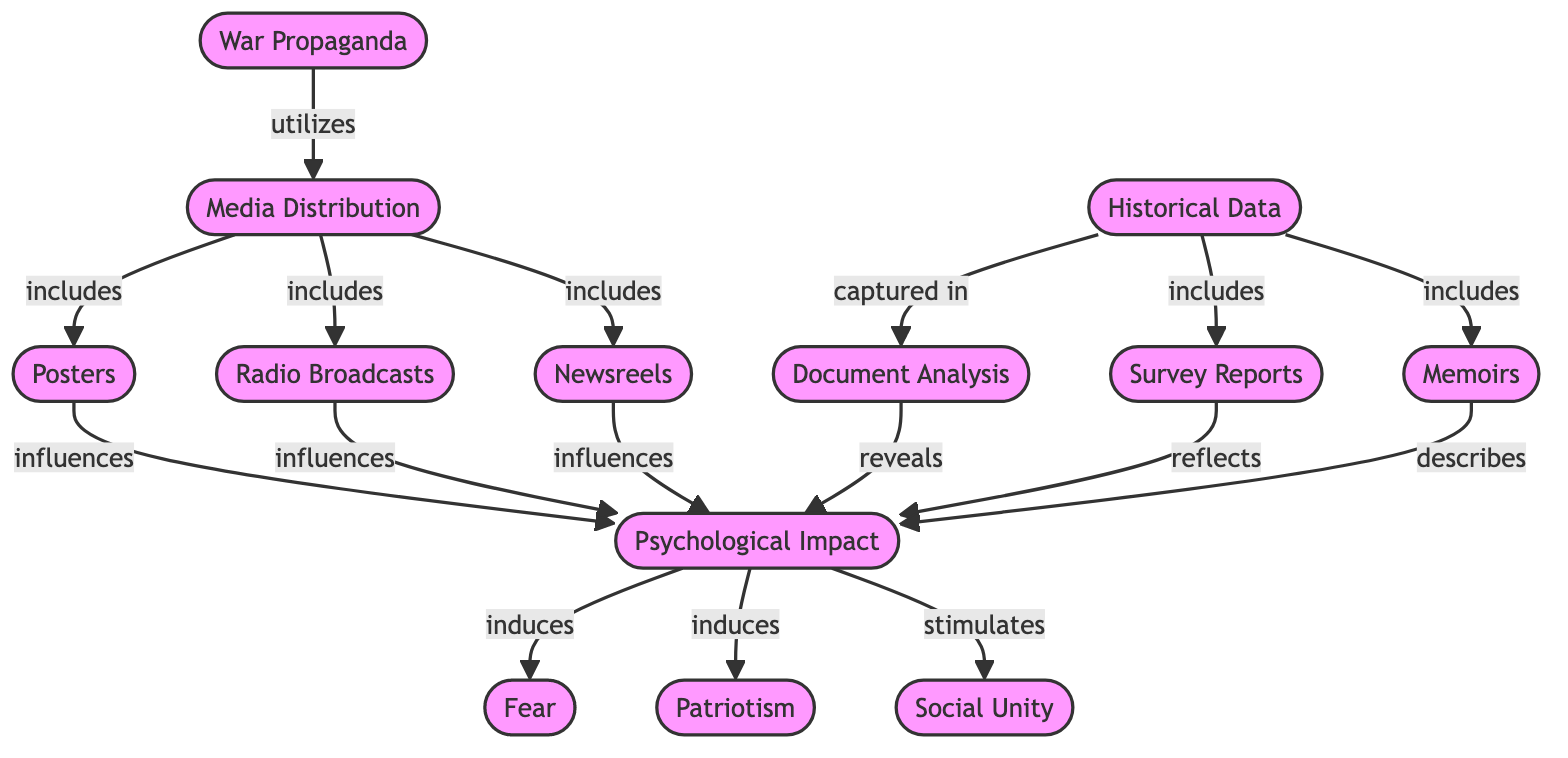What is the main topic of the directed graph? The diagram focuses on the "War Propaganda" and its implications during World War II, specifically how it affects psychological well-being.
Answer: War Propaganda How many nodes are there in the diagram? By counting each unique node labeled in the diagram, we find there are 12 distinct nodes present.
Answer: 12 Which node influences the "Psychological Impact" through "Posters"? The edge shows that "Posters" directly influences the "Psychological Impact," indicating this specific relationship in the diagram.
Answer: Posters What are the three psychological effects induced by the "Psychological Impact"? The edges leading from "Psychological Impact" are analyzed, showing that it induces "Fear," "Patriotism," and stimulates "Social Unity."
Answer: Fear, Patriotism, Social Unity What type of media is included under "Media Distribution"? The labels and directed edges reveal that "Media Distribution" includes "Posters," "Radio Broadcasts," and "Newsreels."
Answer: Posters, Radio Broadcasts, Newsreels What does "Document Analysis" reveal about the "Psychological Impact"? Following the directed edge from "Document Analysis" to "Psychological Impact," we see that it reveals information concerning the psychological effects explored in the diagram.
Answer: reveals Which node provides survey data related to the "Psychological Impact"? The connection indicates that "Survey Reports" are among the nodes that contribute information reflecting the "Psychological Impact."
Answer: Survey Reports Which node leads to "Fear"? Analyzing the directed edges shows that "Psychological Impact" leads to "Fear," indicating a direct relationship where one induces the other.
Answer: Psychological Impact How is "Historical Data" represented in the diagram? The relationships show that "Historical Data" is connected to "Document Analysis," "Survey Reports," and "Memoirs," representing various forms of documentation.
Answer: captured in, includes, includes 